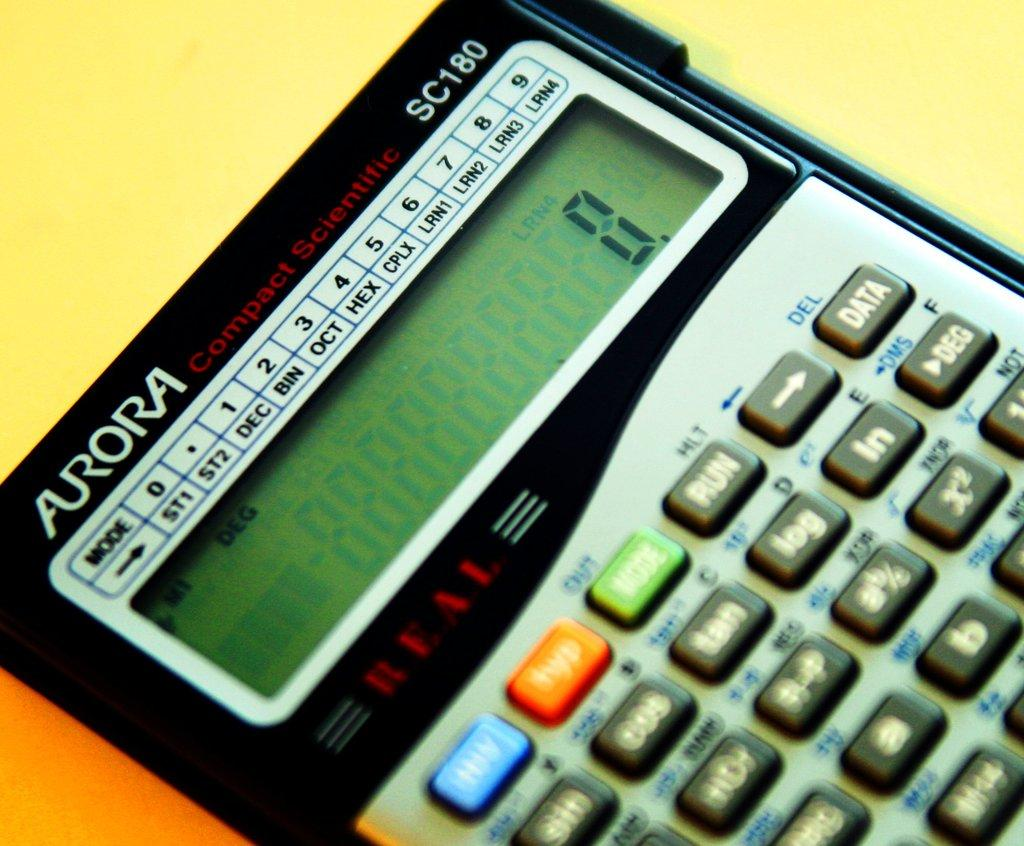<image>
Relay a brief, clear account of the picture shown. An Aurora compact scientific calculator currently reads 0. 